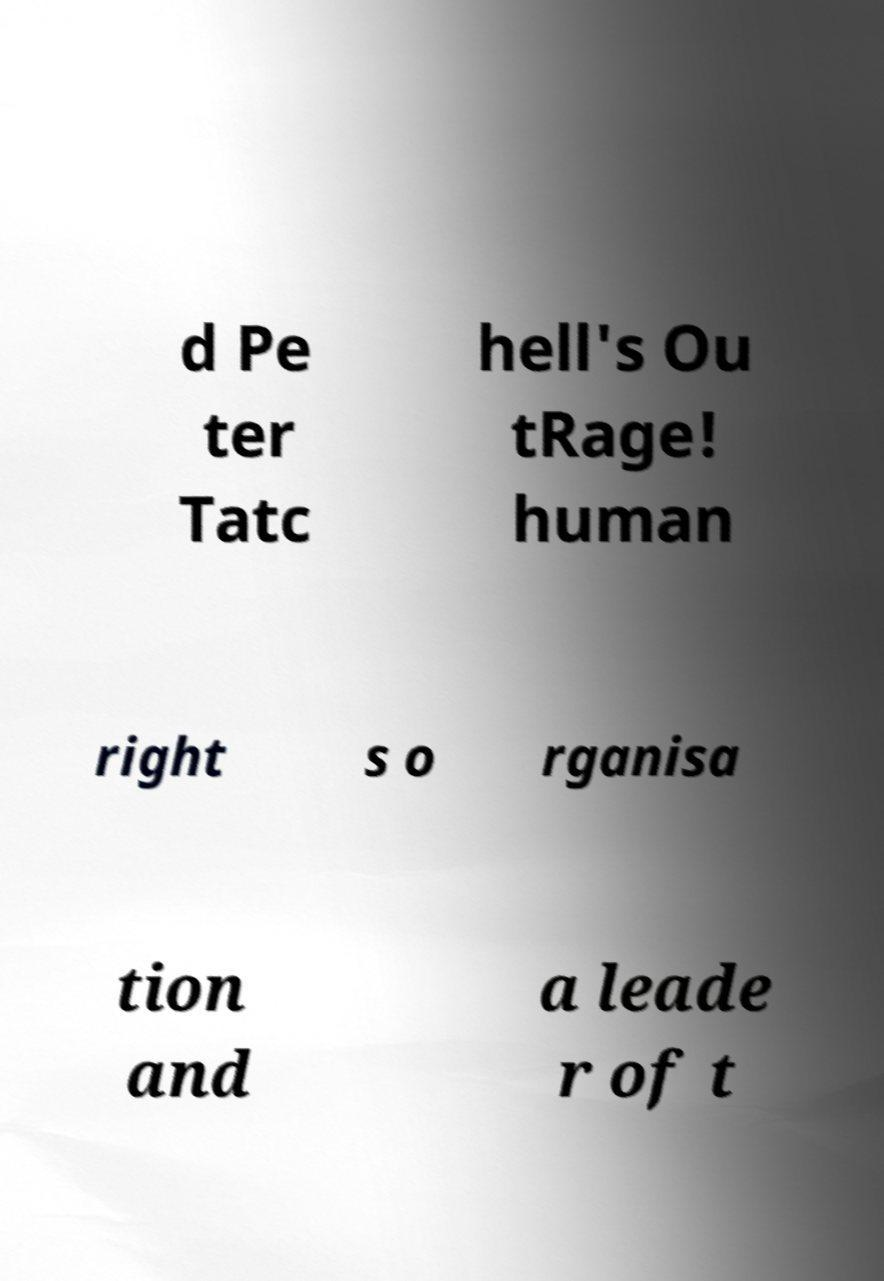Can you read and provide the text displayed in the image?This photo seems to have some interesting text. Can you extract and type it out for me? d Pe ter Tatc hell's Ou tRage! human right s o rganisa tion and a leade r of t 